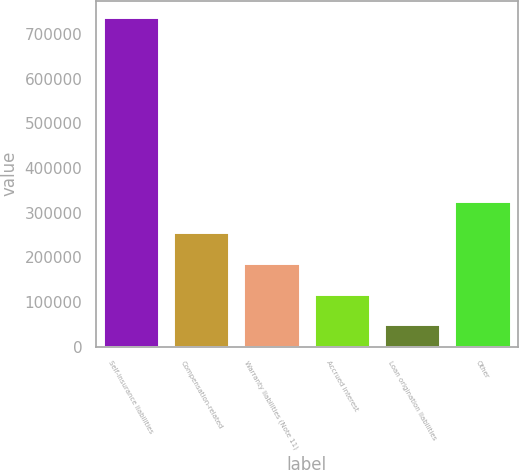<chart> <loc_0><loc_0><loc_500><loc_500><bar_chart><fcel>Self-insurance liabilities<fcel>Compensation-related<fcel>Warranty liabilities (Note 11)<fcel>Accrued interest<fcel>Loan origination liabilities<fcel>Other<nl><fcel>737013<fcel>256301<fcel>187628<fcel>118955<fcel>50282<fcel>324974<nl></chart> 